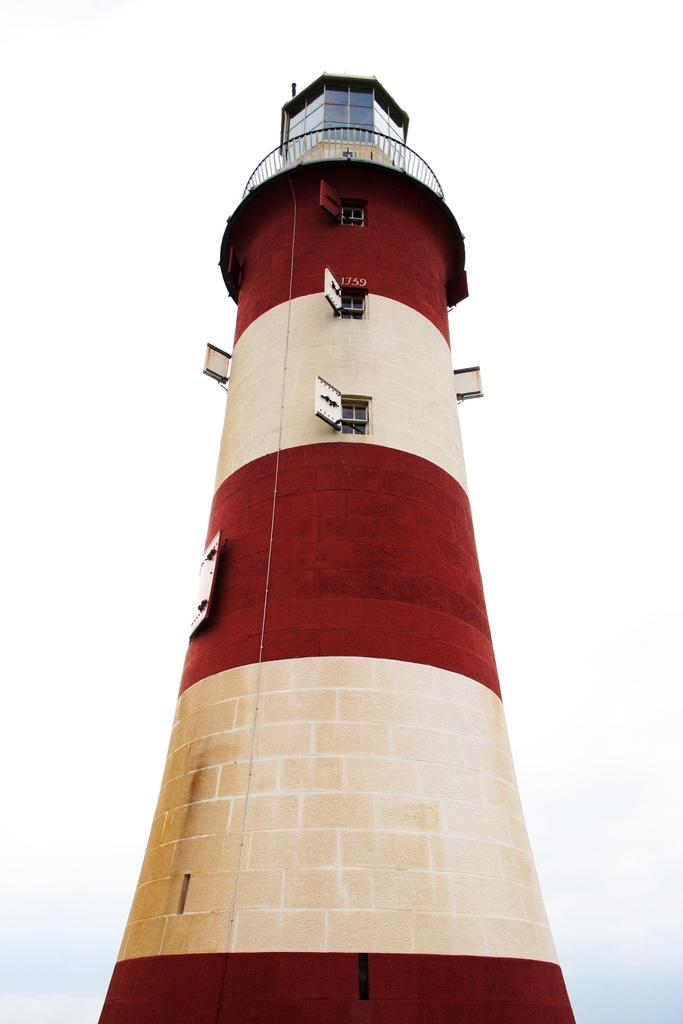What is the main structure visible in the image? There is a lighthouse in the image. Can you describe the lighthouse in more detail? Unfortunately, the provided facts do not offer any additional details about the lighthouse. What might be the purpose of the lighthouse in the image? The lighthouse's purpose is likely to serve as a navigational aid for ships, but this cannot be confirmed without more information. What type of needle is being used to sew the word "hope" onto the lighthouse in the image? There is no needle or word "hope" present in the image; it only features a lighthouse. 